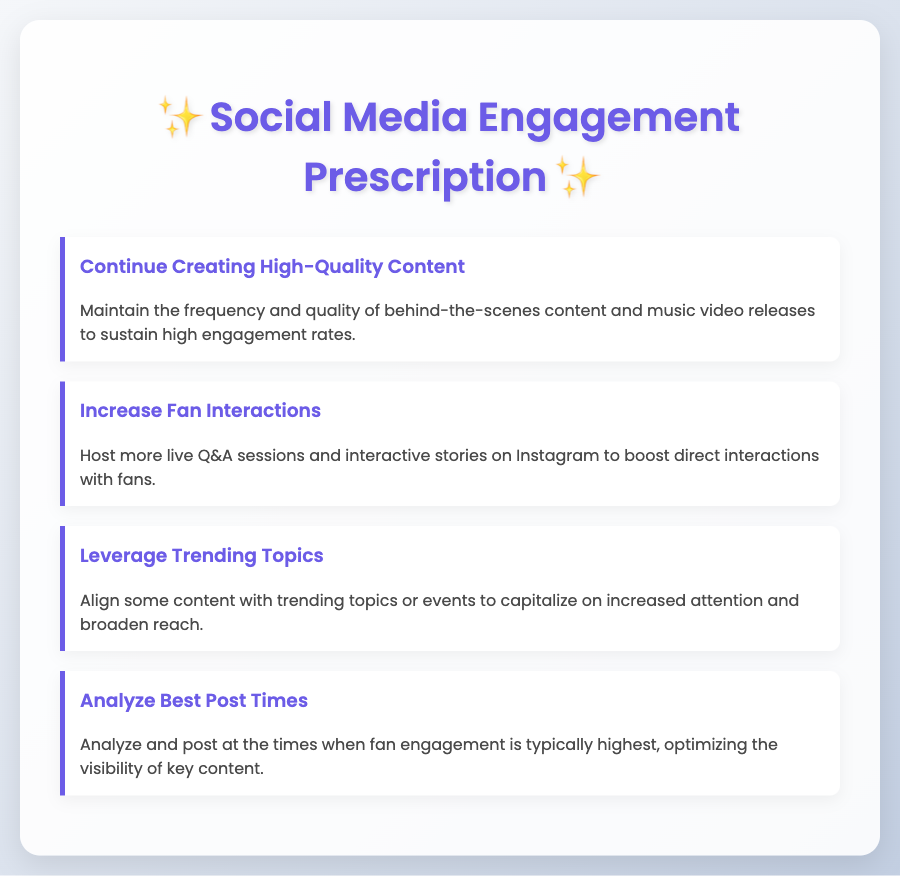what is the title of the document? The title is located in the header of the document and refers to its content focus.
Answer: Social Media Engagement Prescription how many prescription items are listed? The total number of listed prescription items can be counted from the document.
Answer: 4 what is the color of the heading text? The color of the heading text is specified in the styling portion of the document, highlighting its theme.
Answer: #6c5ce7 what is the main recommendation in the first prescription item? The content of the first prescription item indicates the recommendation given for maintaining engagement.
Answer: Continue Creating High-Quality Content which social media platform is mentioned for interactions? The specific platform mentioned in the second prescription item highlights the platform for fan interactions.
Answer: Instagram what is the suggested action regarding trending topics? The third prescription item provides a clear recommendation on how to utilize trending topics effectively.
Answer: Leverage Trending Topics what should be analyzed according to the fourth prescription item? The specific focus of the fourth prescription item suggests an action that contributes to optimizing post visibility.
Answer: Best Post Times what is the overall theme of the document? The theme is inferred from the title and content discussing strategies for connecting with fans online.
Answer: Engagement 